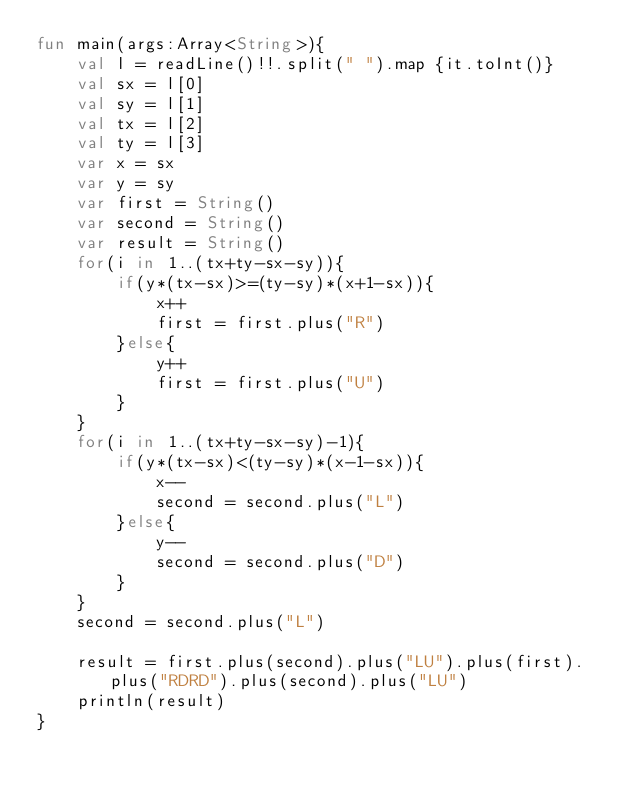Convert code to text. <code><loc_0><loc_0><loc_500><loc_500><_Kotlin_>fun main(args:Array<String>){
    val l = readLine()!!.split(" ").map {it.toInt()}
    val sx = l[0]
    val sy = l[1]
    val tx = l[2]
    val ty = l[3]
    var x = sx
    var y = sy
    var first = String()
    var second = String()
    var result = String()
    for(i in 1..(tx+ty-sx-sy)){
        if(y*(tx-sx)>=(ty-sy)*(x+1-sx)){
            x++
            first = first.plus("R")
        }else{
            y++
            first = first.plus("U")
        }
    }
    for(i in 1..(tx+ty-sx-sy)-1){
        if(y*(tx-sx)<(ty-sy)*(x-1-sx)){
            x--
            second = second.plus("L")
        }else{
            y--
            second = second.plus("D")
        }
    }
    second = second.plus("L")

    result = first.plus(second).plus("LU").plus(first).plus("RDRD").plus(second).plus("LU")
    println(result)
}</code> 